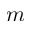Convert formula to latex. <formula><loc_0><loc_0><loc_500><loc_500>m</formula> 